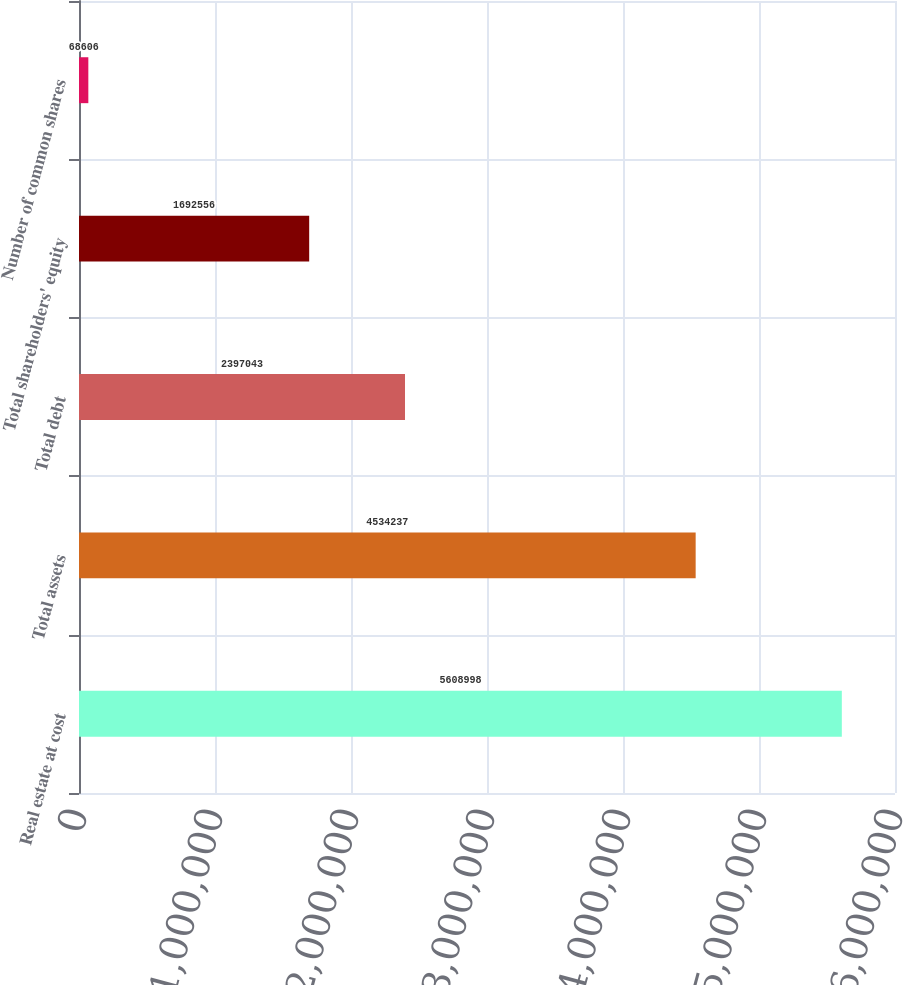<chart> <loc_0><loc_0><loc_500><loc_500><bar_chart><fcel>Real estate at cost<fcel>Total assets<fcel>Total debt<fcel>Total shareholders' equity<fcel>Number of common shares<nl><fcel>5.609e+06<fcel>4.53424e+06<fcel>2.39704e+06<fcel>1.69256e+06<fcel>68606<nl></chart> 